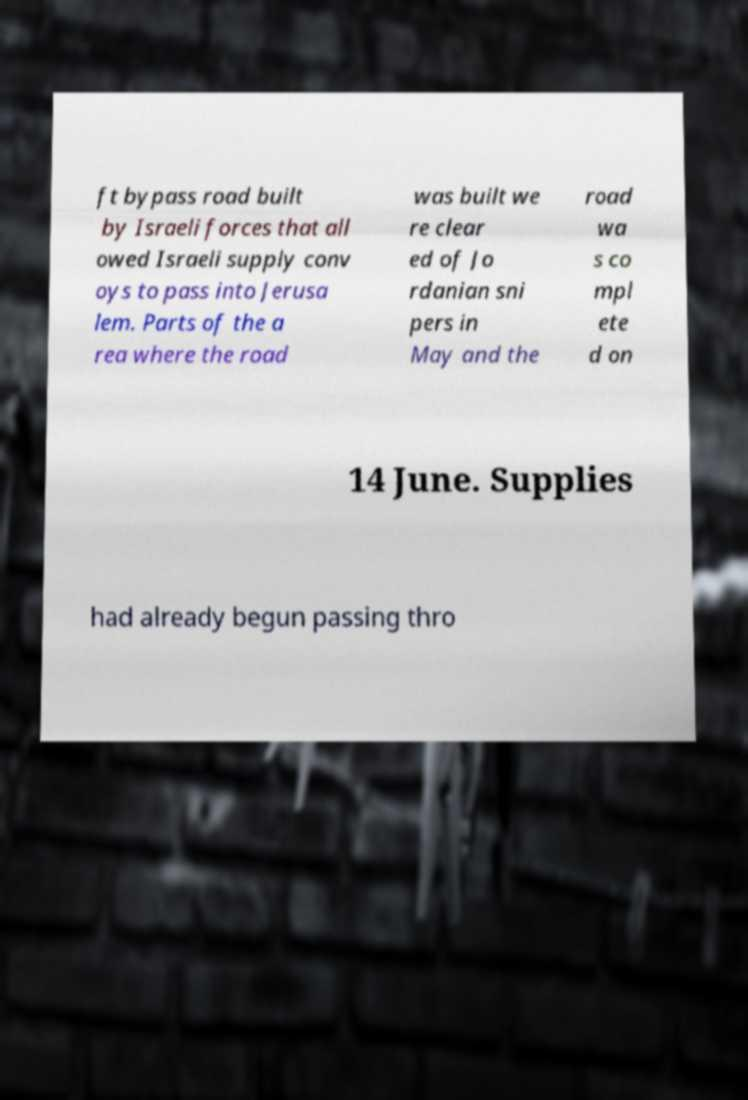There's text embedded in this image that I need extracted. Can you transcribe it verbatim? ft bypass road built by Israeli forces that all owed Israeli supply conv oys to pass into Jerusa lem. Parts of the a rea where the road was built we re clear ed of Jo rdanian sni pers in May and the road wa s co mpl ete d on 14 June. Supplies had already begun passing thro 